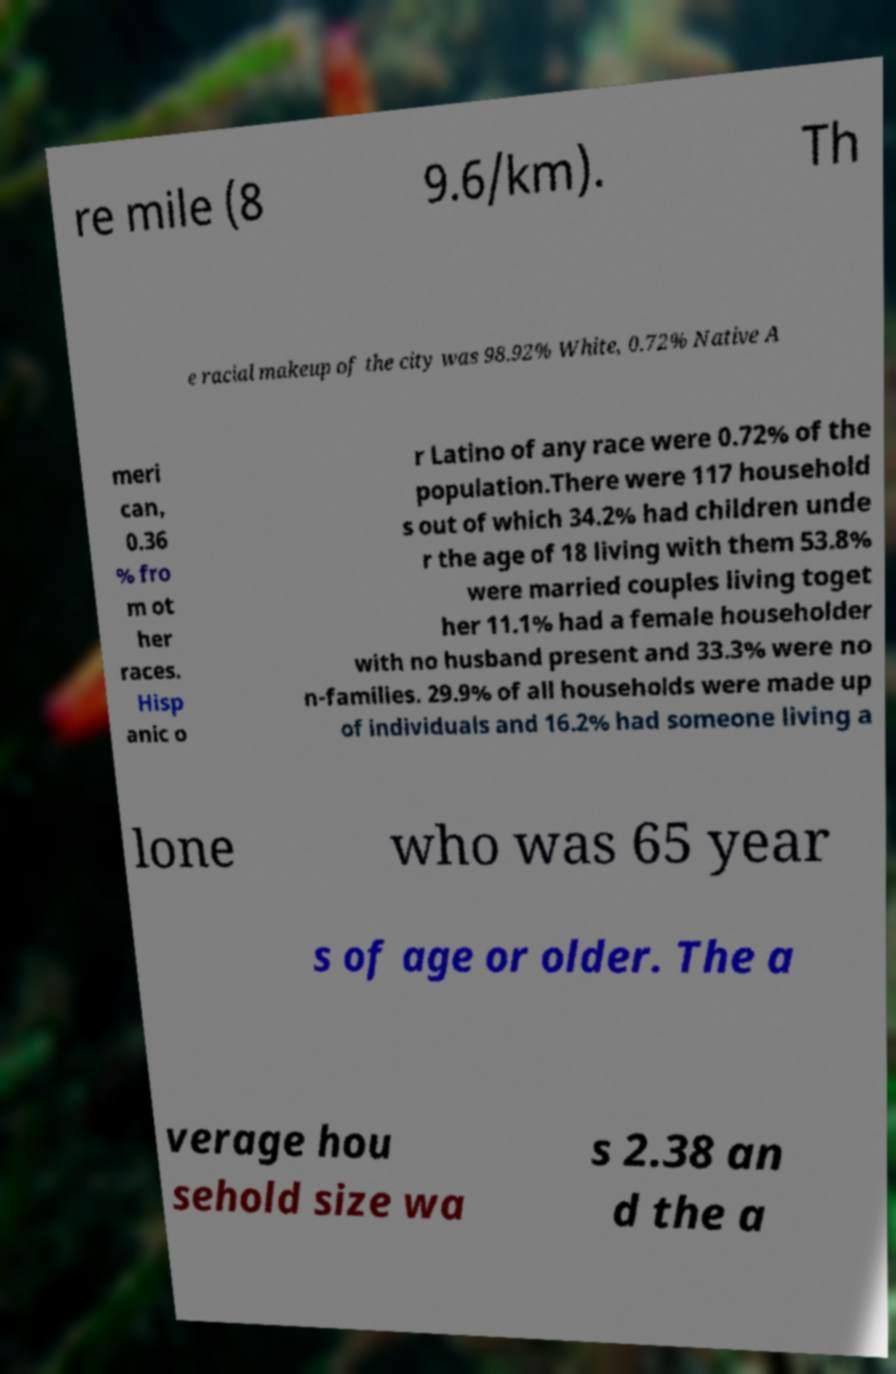Please read and relay the text visible in this image. What does it say? re mile (8 9.6/km). Th e racial makeup of the city was 98.92% White, 0.72% Native A meri can, 0.36 % fro m ot her races. Hisp anic o r Latino of any race were 0.72% of the population.There were 117 household s out of which 34.2% had children unde r the age of 18 living with them 53.8% were married couples living toget her 11.1% had a female householder with no husband present and 33.3% were no n-families. 29.9% of all households were made up of individuals and 16.2% had someone living a lone who was 65 year s of age or older. The a verage hou sehold size wa s 2.38 an d the a 